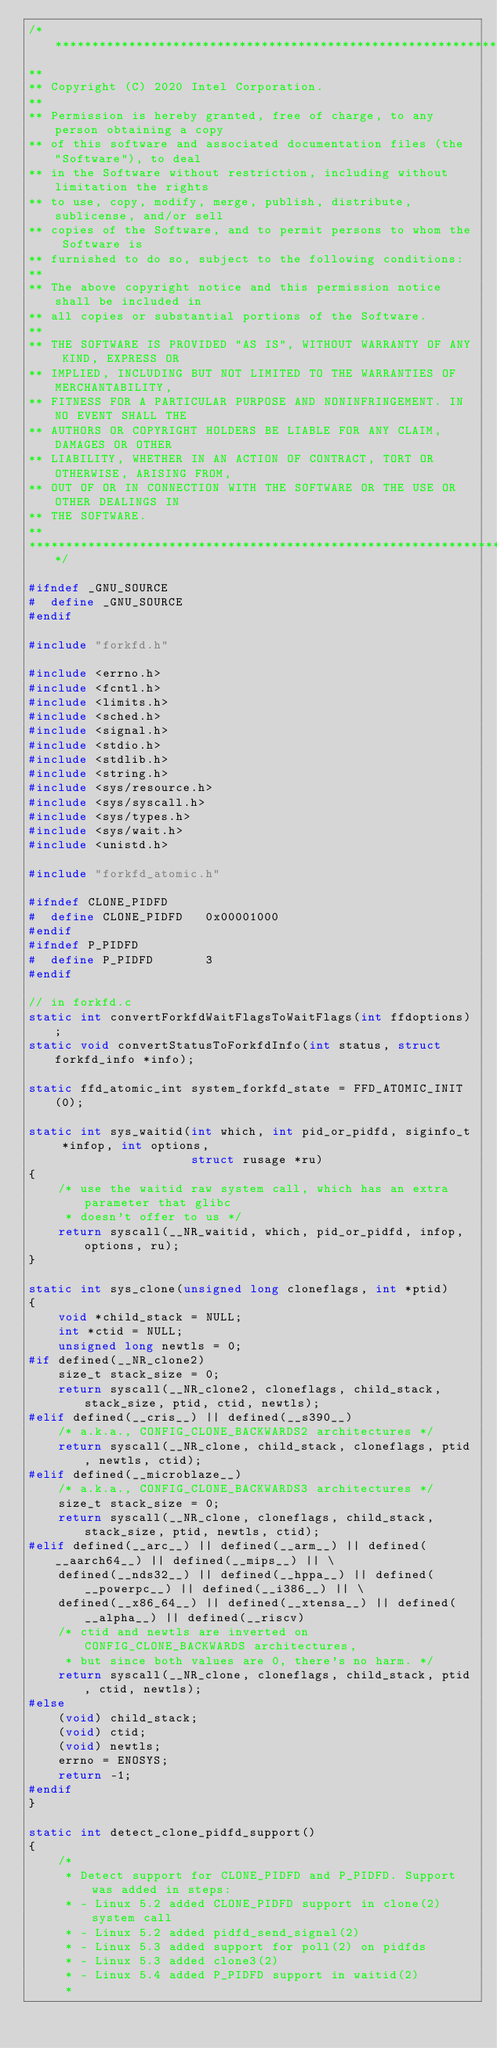<code> <loc_0><loc_0><loc_500><loc_500><_C_>/****************************************************************************
**
** Copyright (C) 2020 Intel Corporation.
**
** Permission is hereby granted, free of charge, to any person obtaining a copy
** of this software and associated documentation files (the "Software"), to deal
** in the Software without restriction, including without limitation the rights
** to use, copy, modify, merge, publish, distribute, sublicense, and/or sell
** copies of the Software, and to permit persons to whom the Software is
** furnished to do so, subject to the following conditions:
**
** The above copyright notice and this permission notice shall be included in
** all copies or substantial portions of the Software.
**
** THE SOFTWARE IS PROVIDED "AS IS", WITHOUT WARRANTY OF ANY KIND, EXPRESS OR
** IMPLIED, INCLUDING BUT NOT LIMITED TO THE WARRANTIES OF MERCHANTABILITY,
** FITNESS FOR A PARTICULAR PURPOSE AND NONINFRINGEMENT. IN NO EVENT SHALL THE
** AUTHORS OR COPYRIGHT HOLDERS BE LIABLE FOR ANY CLAIM, DAMAGES OR OTHER
** LIABILITY, WHETHER IN AN ACTION OF CONTRACT, TORT OR OTHERWISE, ARISING FROM,
** OUT OF OR IN CONNECTION WITH THE SOFTWARE OR THE USE OR OTHER DEALINGS IN
** THE SOFTWARE.
**
****************************************************************************/

#ifndef _GNU_SOURCE
#  define _GNU_SOURCE
#endif

#include "forkfd.h"

#include <errno.h>
#include <fcntl.h>
#include <limits.h>
#include <sched.h>
#include <signal.h>
#include <stdio.h>
#include <stdlib.h>
#include <string.h>
#include <sys/resource.h>
#include <sys/syscall.h>
#include <sys/types.h>
#include <sys/wait.h>
#include <unistd.h>

#include "forkfd_atomic.h"

#ifndef CLONE_PIDFD
#  define CLONE_PIDFD   0x00001000
#endif
#ifndef P_PIDFD
#  define P_PIDFD       3
#endif

// in forkfd.c
static int convertForkfdWaitFlagsToWaitFlags(int ffdoptions);
static void convertStatusToForkfdInfo(int status, struct forkfd_info *info);

static ffd_atomic_int system_forkfd_state = FFD_ATOMIC_INIT(0);

static int sys_waitid(int which, int pid_or_pidfd, siginfo_t *infop, int options,
                      struct rusage *ru)
{
    /* use the waitid raw system call, which has an extra parameter that glibc
     * doesn't offer to us */
    return syscall(__NR_waitid, which, pid_or_pidfd, infop, options, ru);
}

static int sys_clone(unsigned long cloneflags, int *ptid)
{
    void *child_stack = NULL;
    int *ctid = NULL;
    unsigned long newtls = 0;
#if defined(__NR_clone2)
    size_t stack_size = 0;
    return syscall(__NR_clone2, cloneflags, child_stack, stack_size, ptid, ctid, newtls);
#elif defined(__cris__) || defined(__s390__)
    /* a.k.a., CONFIG_CLONE_BACKWARDS2 architectures */
    return syscall(__NR_clone, child_stack, cloneflags, ptid, newtls, ctid);
#elif defined(__microblaze__)
    /* a.k.a., CONFIG_CLONE_BACKWARDS3 architectures */
    size_t stack_size = 0;
    return syscall(__NR_clone, cloneflags, child_stack, stack_size, ptid, newtls, ctid);
#elif defined(__arc__) || defined(__arm__) || defined(__aarch64__) || defined(__mips__) || \
    defined(__nds32__) || defined(__hppa__) || defined(__powerpc__) || defined(__i386__) || \
    defined(__x86_64__) || defined(__xtensa__) || defined(__alpha__) || defined(__riscv)
    /* ctid and newtls are inverted on CONFIG_CLONE_BACKWARDS architectures,
     * but since both values are 0, there's no harm. */
    return syscall(__NR_clone, cloneflags, child_stack, ptid, ctid, newtls);
#else
    (void) child_stack;
    (void) ctid;
    (void) newtls;
    errno = ENOSYS;
    return -1;
#endif
}

static int detect_clone_pidfd_support()
{
    /*
     * Detect support for CLONE_PIDFD and P_PIDFD. Support was added in steps:
     * - Linux 5.2 added CLONE_PIDFD support in clone(2) system call
     * - Linux 5.2 added pidfd_send_signal(2)
     * - Linux 5.3 added support for poll(2) on pidfds
     * - Linux 5.3 added clone3(2)
     * - Linux 5.4 added P_PIDFD support in waitid(2)
     *</code> 